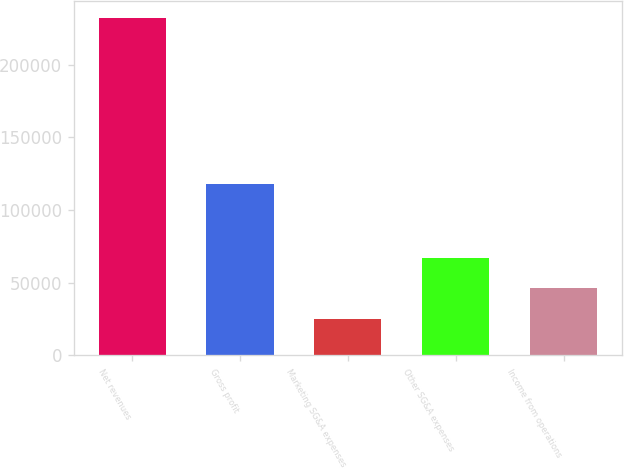Convert chart to OTSL. <chart><loc_0><loc_0><loc_500><loc_500><bar_chart><fcel>Net revenues<fcel>Gross profit<fcel>Marketing SG&A expenses<fcel>Other SG&A expenses<fcel>Income from operations<nl><fcel>231946<fcel>118267<fcel>24783<fcel>67195.3<fcel>46479<nl></chart> 